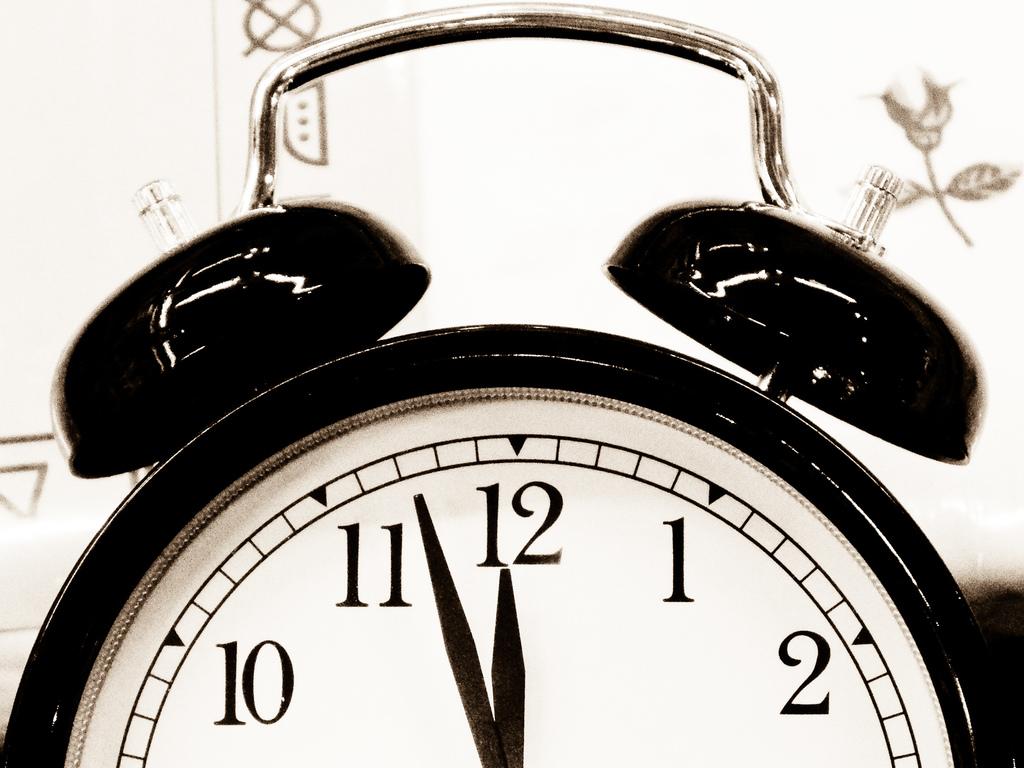What time is it?
Keep it short and to the point. 11:57. 